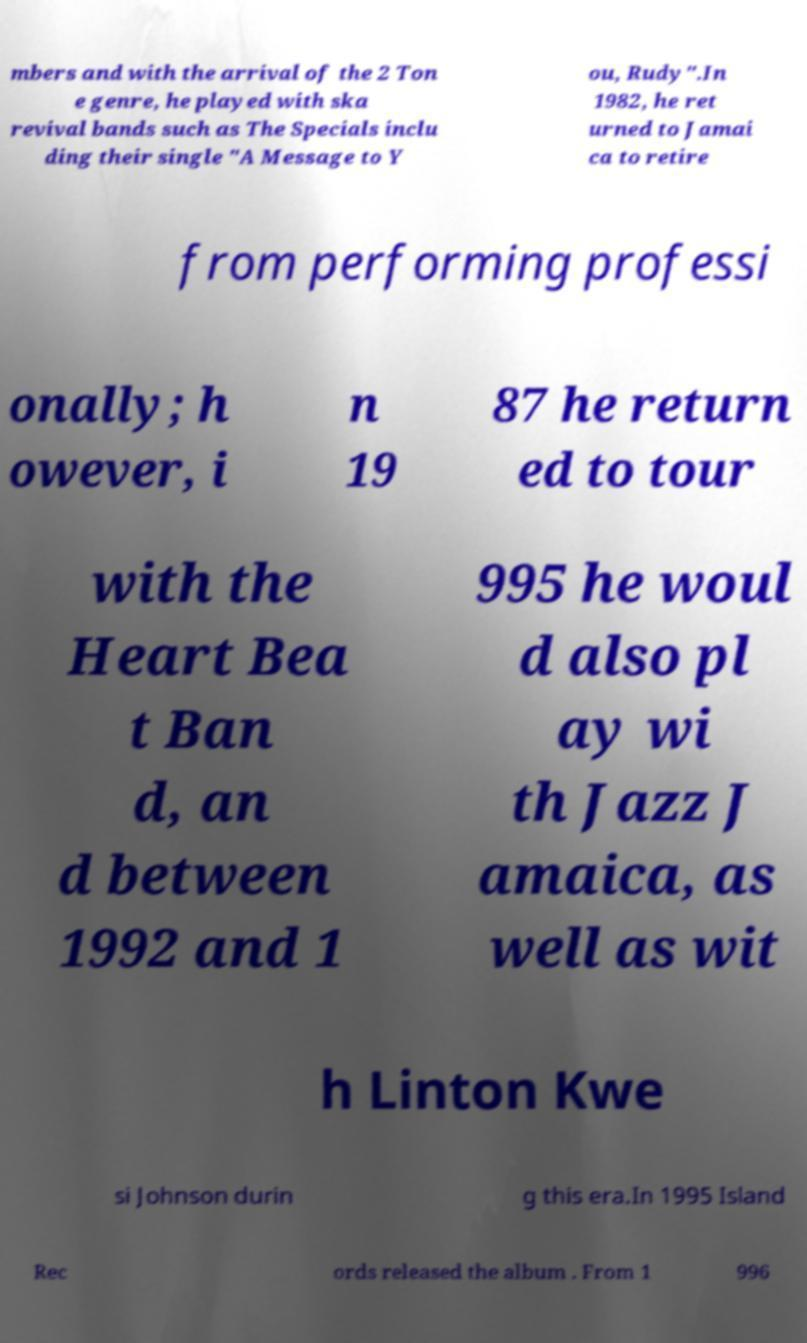Please read and relay the text visible in this image. What does it say? mbers and with the arrival of the 2 Ton e genre, he played with ska revival bands such as The Specials inclu ding their single "A Message to Y ou, Rudy".In 1982, he ret urned to Jamai ca to retire from performing professi onally; h owever, i n 19 87 he return ed to tour with the Heart Bea t Ban d, an d between 1992 and 1 995 he woul d also pl ay wi th Jazz J amaica, as well as wit h Linton Kwe si Johnson durin g this era.In 1995 Island Rec ords released the album . From 1 996 